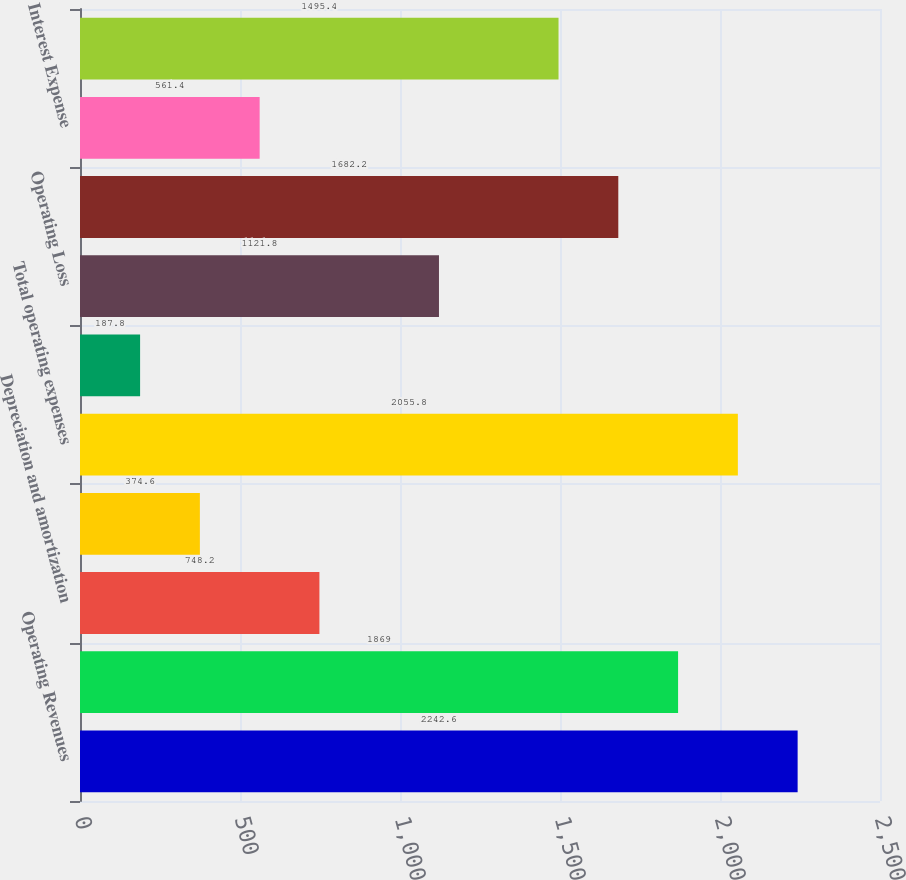Convert chart. <chart><loc_0><loc_0><loc_500><loc_500><bar_chart><fcel>Operating Revenues<fcel>Operation maintenance and<fcel>Depreciation and amortization<fcel>Property and other taxes<fcel>Total operating expenses<fcel>Gains on Sales of Other Assets<fcel>Operating Loss<fcel>Other Income and Expenses<fcel>Interest Expense<fcel>Loss Before Income Taxes<nl><fcel>2242.6<fcel>1869<fcel>748.2<fcel>374.6<fcel>2055.8<fcel>187.8<fcel>1121.8<fcel>1682.2<fcel>561.4<fcel>1495.4<nl></chart> 